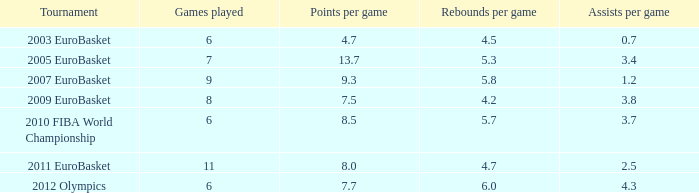How many games played have 4.7 points per game? 1.0. Can you parse all the data within this table? {'header': ['Tournament', 'Games played', 'Points per game', 'Rebounds per game', 'Assists per game'], 'rows': [['2003 EuroBasket', '6', '4.7', '4.5', '0.7'], ['2005 EuroBasket', '7', '13.7', '5.3', '3.4'], ['2007 EuroBasket', '9', '9.3', '5.8', '1.2'], ['2009 EuroBasket', '8', '7.5', '4.2', '3.8'], ['2010 FIBA World Championship', '6', '8.5', '5.7', '3.7'], ['2011 EuroBasket', '11', '8.0', '4.7', '2.5'], ['2012 Olympics', '6', '7.7', '6.0', '4.3']]} 